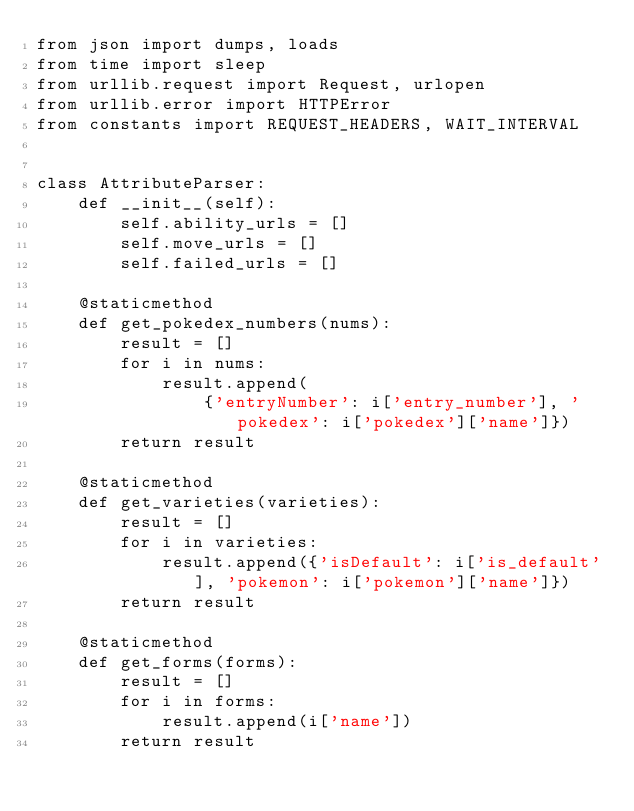<code> <loc_0><loc_0><loc_500><loc_500><_Python_>from json import dumps, loads
from time import sleep
from urllib.request import Request, urlopen
from urllib.error import HTTPError
from constants import REQUEST_HEADERS, WAIT_INTERVAL


class AttributeParser:
    def __init__(self):
        self.ability_urls = []
        self.move_urls = []
        self.failed_urls = []

    @staticmethod
    def get_pokedex_numbers(nums):
        result = []
        for i in nums:
            result.append(
                {'entryNumber': i['entry_number'], 'pokedex': i['pokedex']['name']})
        return result

    @staticmethod
    def get_varieties(varieties):
        result = []
        for i in varieties:
            result.append({'isDefault': i['is_default'], 'pokemon': i['pokemon']['name']})
        return result

    @staticmethod
    def get_forms(forms):
        result = []
        for i in forms:
            result.append(i['name'])
        return result
</code> 